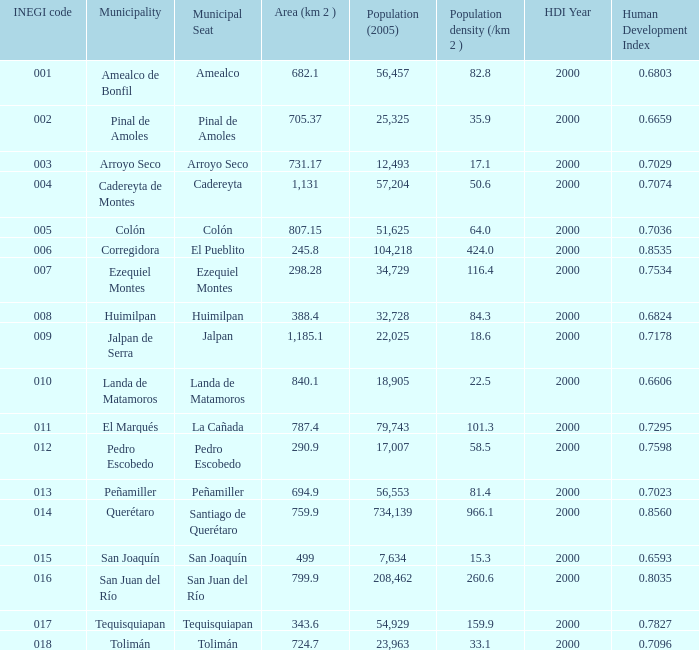WHich INEGI code has a Population density (/km 2 ) smaller than 81.4 and 0.6593 Human Development Index (2000)? 15.0. 